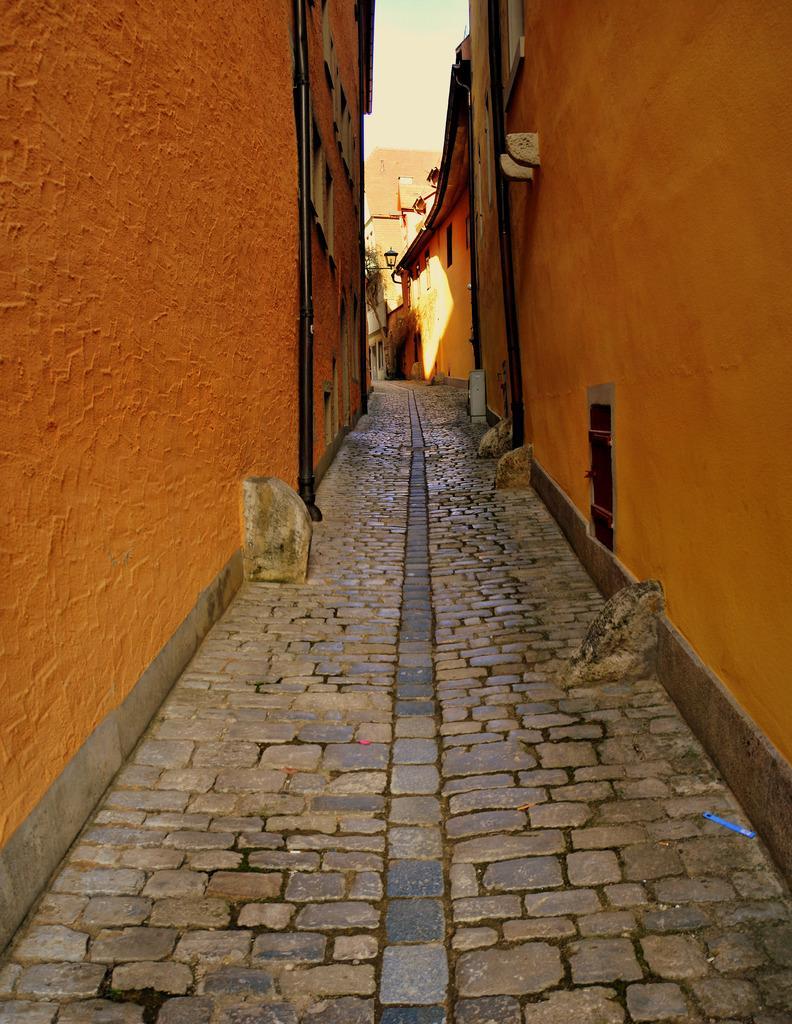How would you summarize this image in a sentence or two? In this image there is a road constructed with stones in between two orange color buildings. 